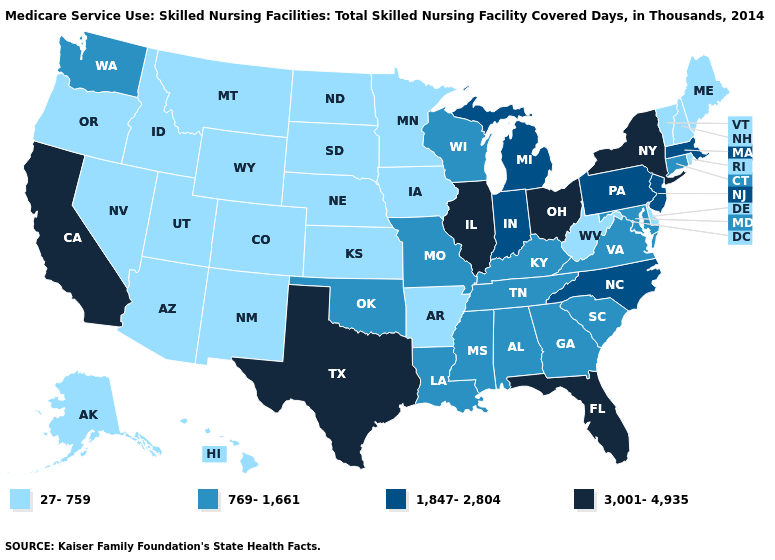Name the states that have a value in the range 1,847-2,804?
Concise answer only. Indiana, Massachusetts, Michigan, New Jersey, North Carolina, Pennsylvania. What is the value of Iowa?
Short answer required. 27-759. Name the states that have a value in the range 769-1,661?
Concise answer only. Alabama, Connecticut, Georgia, Kentucky, Louisiana, Maryland, Mississippi, Missouri, Oklahoma, South Carolina, Tennessee, Virginia, Washington, Wisconsin. What is the highest value in states that border Indiana?
Answer briefly. 3,001-4,935. What is the lowest value in the South?
Quick response, please. 27-759. Which states have the lowest value in the Northeast?
Concise answer only. Maine, New Hampshire, Rhode Island, Vermont. Which states hav the highest value in the West?
Answer briefly. California. Name the states that have a value in the range 3,001-4,935?
Give a very brief answer. California, Florida, Illinois, New York, Ohio, Texas. What is the value of Nevada?
Concise answer only. 27-759. Does New Hampshire have the lowest value in the Northeast?
Keep it brief. Yes. Name the states that have a value in the range 769-1,661?
Concise answer only. Alabama, Connecticut, Georgia, Kentucky, Louisiana, Maryland, Mississippi, Missouri, Oklahoma, South Carolina, Tennessee, Virginia, Washington, Wisconsin. Does the first symbol in the legend represent the smallest category?
Give a very brief answer. Yes. Does Connecticut have the same value as New York?
Give a very brief answer. No. Among the states that border Connecticut , which have the lowest value?
Keep it brief. Rhode Island. What is the highest value in the USA?
Give a very brief answer. 3,001-4,935. 